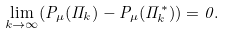Convert formula to latex. <formula><loc_0><loc_0><loc_500><loc_500>\lim _ { k \to \infty } ( P _ { \mu } ( \Pi _ { k } ) - P _ { \mu } ( \Pi _ { k } ^ { * } ) ) = 0 .</formula> 